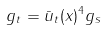Convert formula to latex. <formula><loc_0><loc_0><loc_500><loc_500>g _ { t } = \bar { u } _ { t } ( x ) ^ { 4 } g _ { s }</formula> 